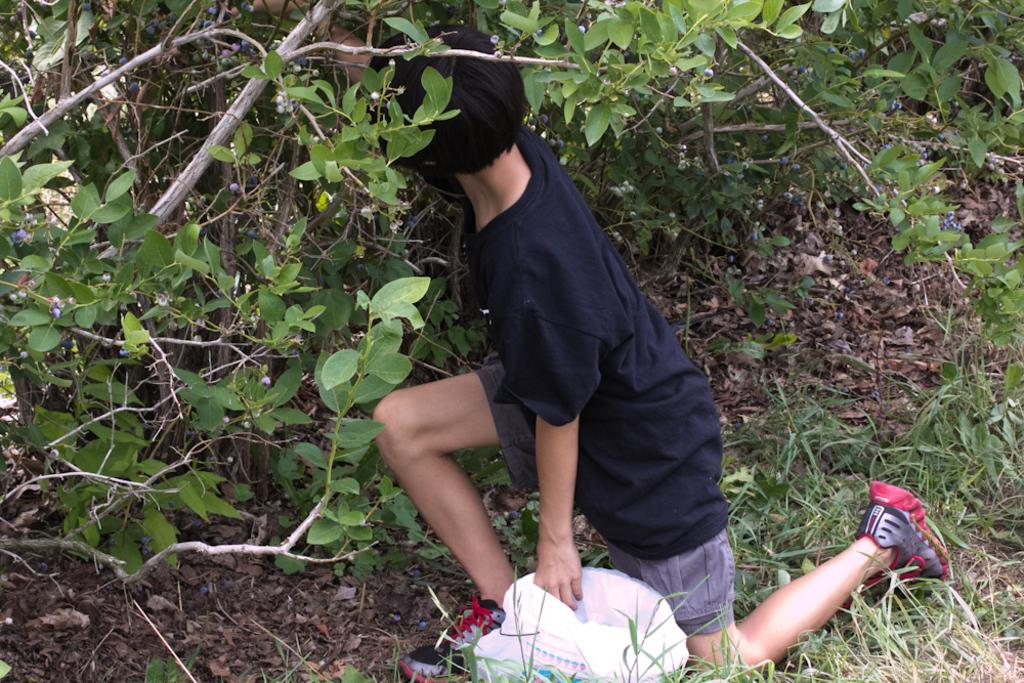Who is the main subject in the image? There is a boy in the image. What is the boy doing in the image? The boy is bending his knees in the image. What can be seen in the background of the image? There are plants in the background of the image. What object is located at the bottom of the image? There is a bag at the bottom of the image. What type of soup is being served in the vessel in the image? There is no vessel or soup present in the image. How does the boy's temper affect the plants in the background? The boy's temper is not mentioned in the image, and there is no indication that it affects the plants. 